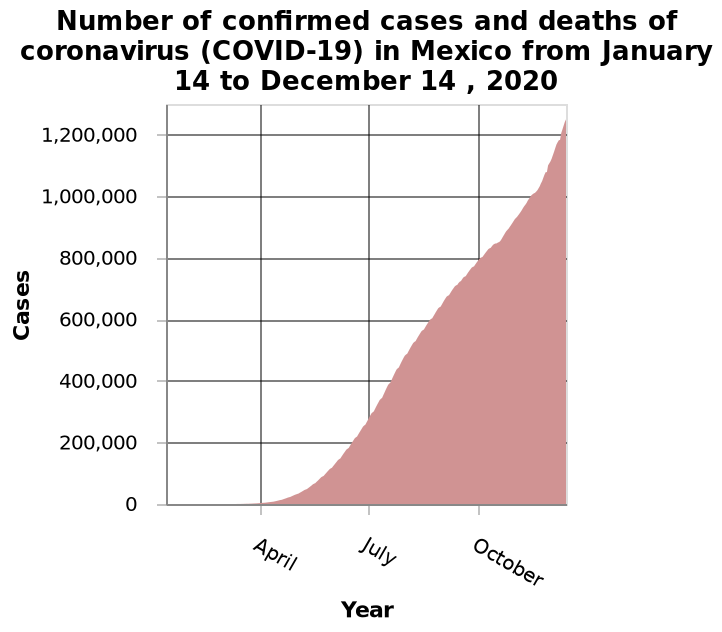<image>
What is being measured along the y-axis? Along the y-axis, the plot measures the number of confirmed cases and deaths of coronavirus (COVID-19) in Mexico. What is being plotted along the x-axis? The x-axis represents the categorical scale from January 14 to December 14, 2020. What was the number of confirmed cases and deaths in April?  The number of confirmed cases and deaths in April was 0. Does the x-axis represent the continuous scale from January 14 to December 14, 2020? No.The x-axis represents the categorical scale from January 14 to December 14, 2020. 